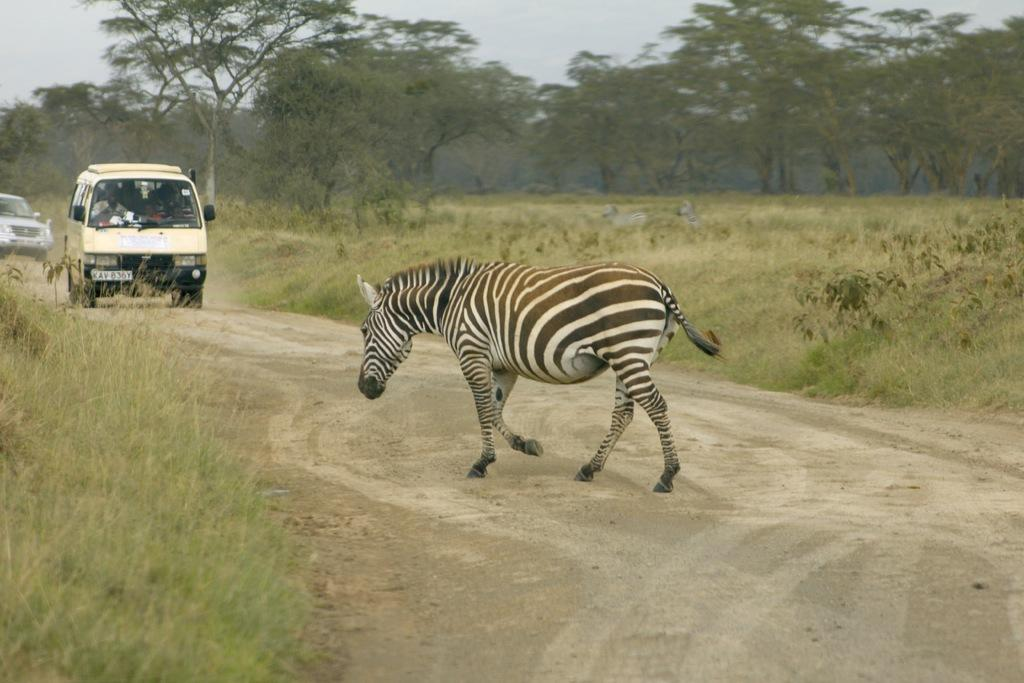What type of animal is in the picture? There is a zebra in the picture. What else can be seen in the picture besides the zebra? There are cars and trees in the picture. What is the ground covered with in the picture? There is grass on the ground in the picture. Where is the boy swimming in the lake in the picture? There is no boy swimming in a lake in the picture; it only features a zebra, cars, trees, and grass. 